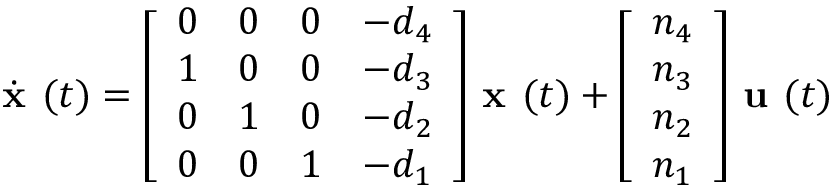Convert formula to latex. <formula><loc_0><loc_0><loc_500><loc_500>{ \dot { x } } ( t ) = { \left [ \begin{array} { l l l l } { 0 } & { 0 } & { 0 } & { - d _ { 4 } } \\ { 1 } & { 0 } & { 0 } & { - d _ { 3 } } \\ { 0 } & { 1 } & { 0 } & { - d _ { 2 } } \\ { 0 } & { 0 } & { 1 } & { - d _ { 1 } } \end{array} \right ] } { x } ( t ) + { \left [ \begin{array} { l } { n _ { 4 } } \\ { n _ { 3 } } \\ { n _ { 2 } } \\ { n _ { 1 } } \end{array} \right ] } { u } ( t )</formula> 